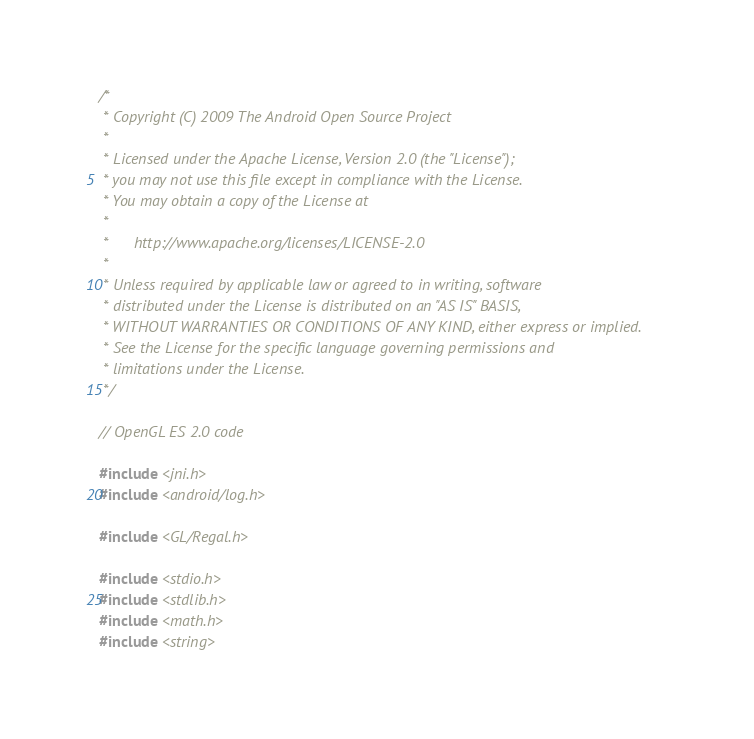Convert code to text. <code><loc_0><loc_0><loc_500><loc_500><_C++_>/*
 * Copyright (C) 2009 The Android Open Source Project
 *
 * Licensed under the Apache License, Version 2.0 (the "License");
 * you may not use this file except in compliance with the License.
 * You may obtain a copy of the License at
 *
 *      http://www.apache.org/licenses/LICENSE-2.0
 *
 * Unless required by applicable law or agreed to in writing, software
 * distributed under the License is distributed on an "AS IS" BASIS,
 * WITHOUT WARRANTIES OR CONDITIONS OF ANY KIND, either express or implied.
 * See the License for the specific language governing permissions and
 * limitations under the License.
 */

// OpenGL ES 2.0 code

#include <jni.h>
#include <android/log.h>

#include <GL/Regal.h>

#include <stdio.h>
#include <stdlib.h>
#include <math.h>
#include <string>
</code> 